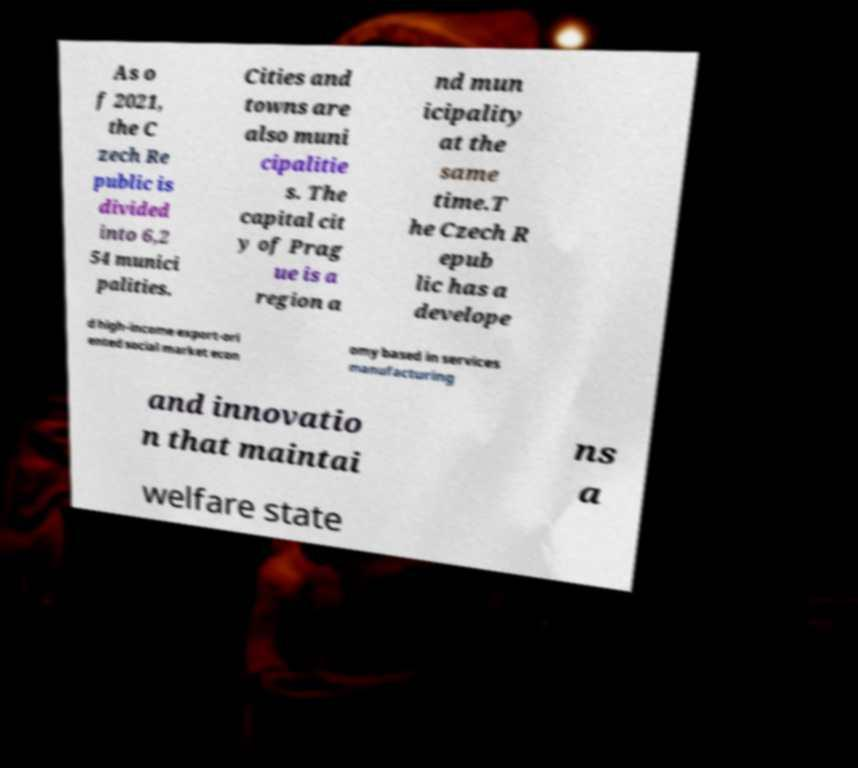Could you assist in decoding the text presented in this image and type it out clearly? As o f 2021, the C zech Re public is divided into 6,2 54 munici palities. Cities and towns are also muni cipalitie s. The capital cit y of Prag ue is a region a nd mun icipality at the same time.T he Czech R epub lic has a develope d high-income export-ori ented social market econ omy based in services manufacturing and innovatio n that maintai ns a welfare state 